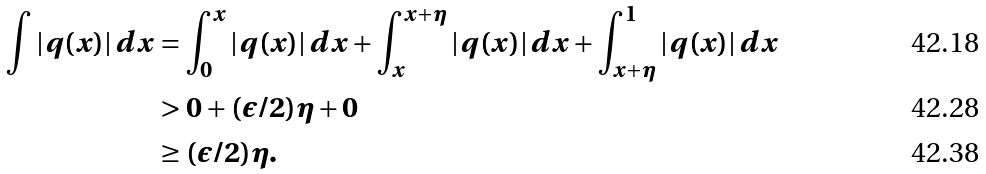<formula> <loc_0><loc_0><loc_500><loc_500>\int | q ( x ) | \, d x & = \int _ { 0 } ^ { x } | q ( x ) | \, d x + \int _ { x } ^ { x + \eta } | q ( x ) | \, d x + \int _ { x + \eta } ^ { 1 } | q ( x ) | \, d x \\ & > 0 + ( \epsilon / 2 ) \eta + 0 \\ & \geq ( \epsilon / 2 ) \eta .</formula> 